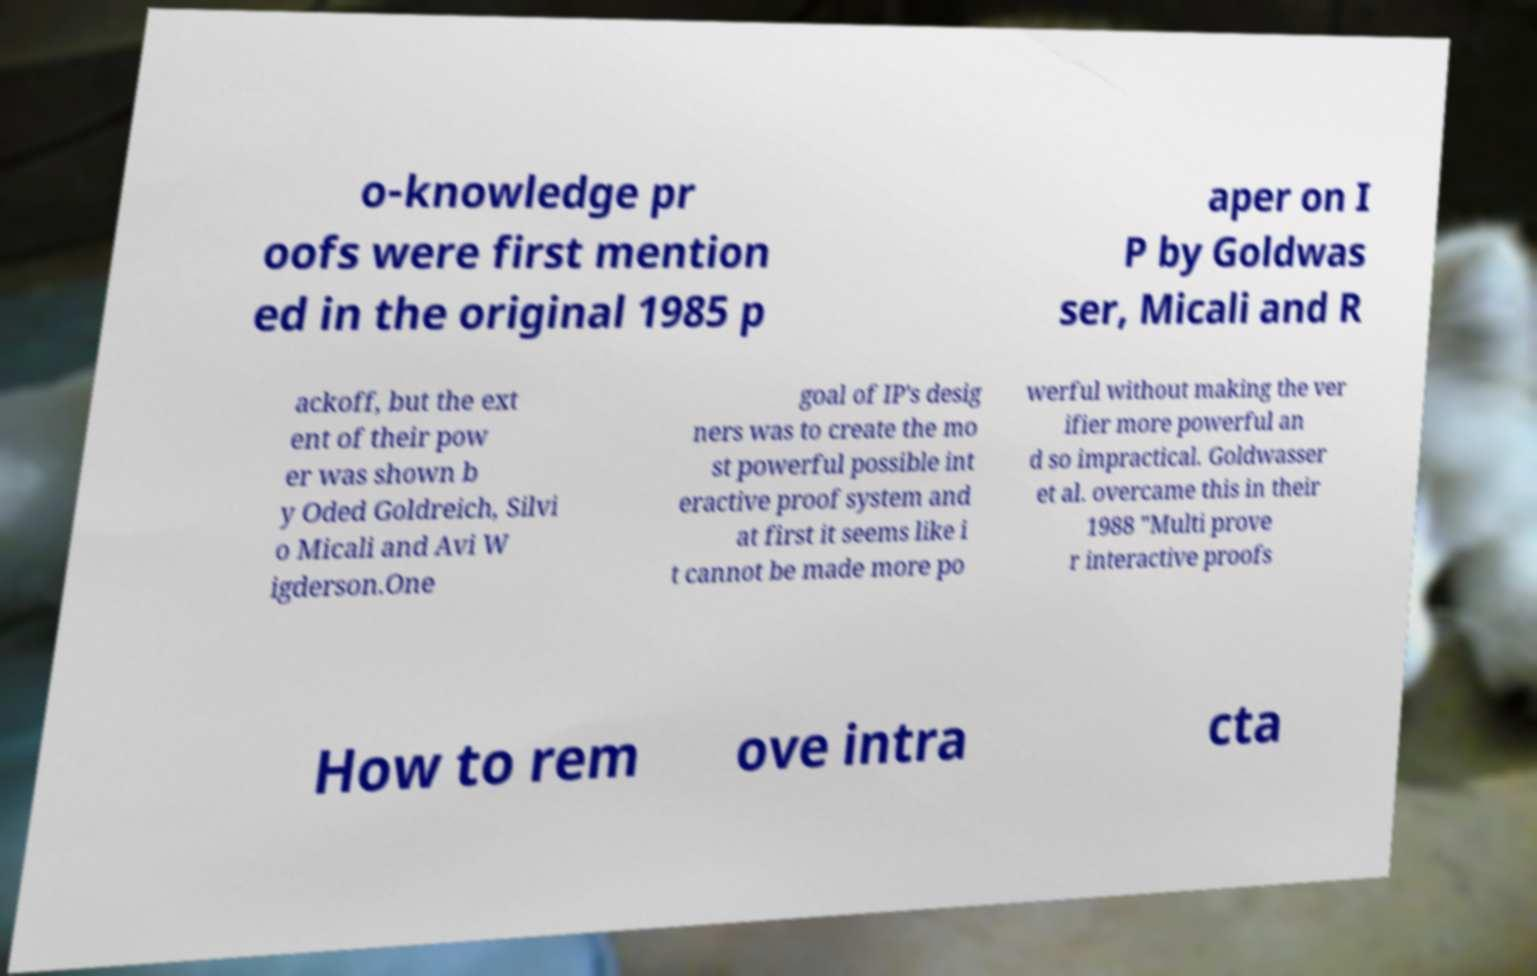Can you read and provide the text displayed in the image?This photo seems to have some interesting text. Can you extract and type it out for me? o-knowledge pr oofs were first mention ed in the original 1985 p aper on I P by Goldwas ser, Micali and R ackoff, but the ext ent of their pow er was shown b y Oded Goldreich, Silvi o Micali and Avi W igderson.One goal of IP's desig ners was to create the mo st powerful possible int eractive proof system and at first it seems like i t cannot be made more po werful without making the ver ifier more powerful an d so impractical. Goldwasser et al. overcame this in their 1988 "Multi prove r interactive proofs How to rem ove intra cta 